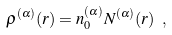<formula> <loc_0><loc_0><loc_500><loc_500>\rho ^ { ( \alpha ) } ( r ) = n _ { 0 } ^ { ( \alpha ) } N ^ { ( \alpha ) } ( r ) \ ,</formula> 